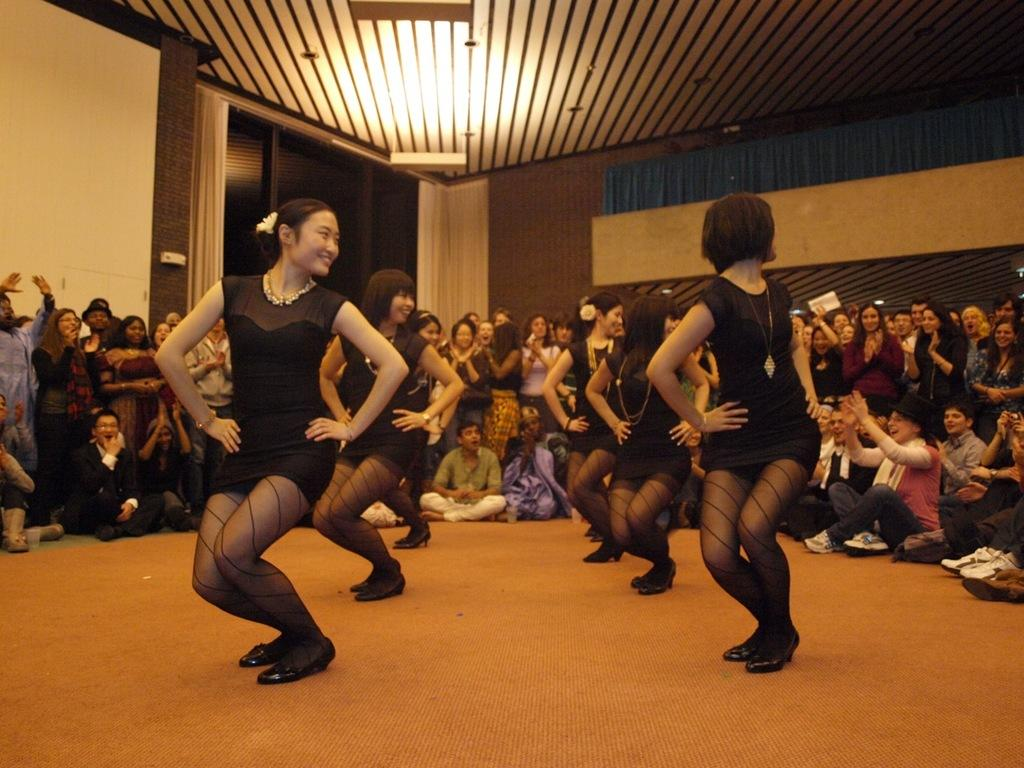How many girls are in the image? There are five girls in the image. What are the girls doing in the image? The girls are dancing. What color are the dresses the girls are wearing? The girls are wearing black dresses. Can you describe the people in the background of the image? The people in the background are cheering. What color are the walls in the image? The walls in the image are brown. What type of wave can be seen crashing on the shore in the image? There is no wave or shore present in the image; it features five girls dancing in black dresses. 